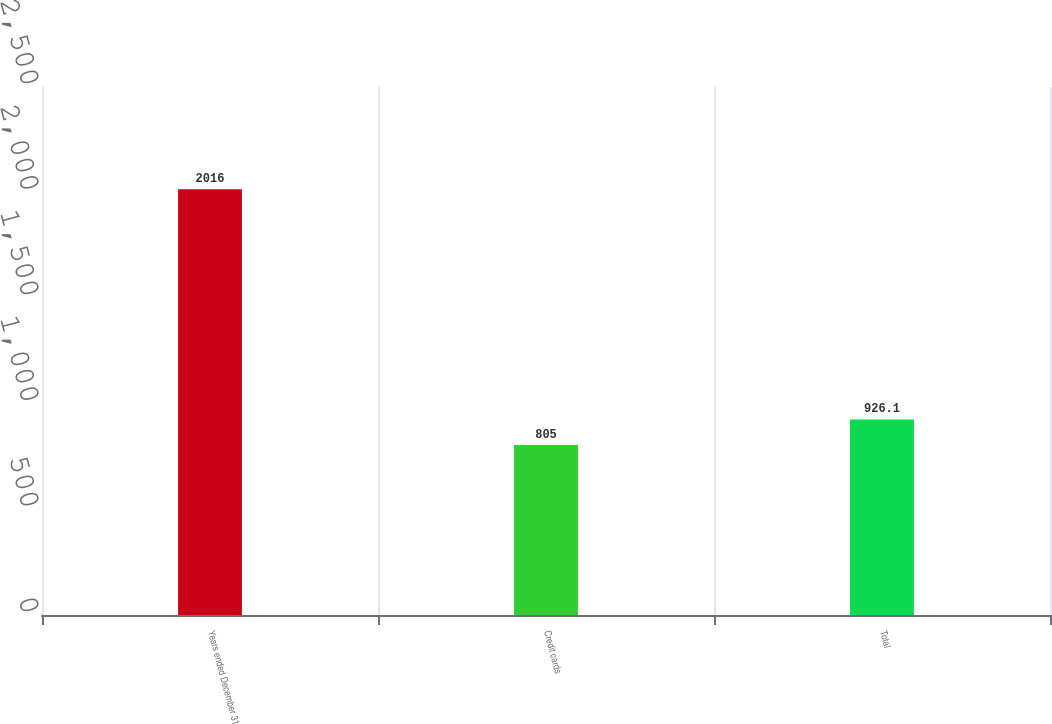Convert chart. <chart><loc_0><loc_0><loc_500><loc_500><bar_chart><fcel>Years ended December 31<fcel>Credit cards<fcel>Total<nl><fcel>2016<fcel>805<fcel>926.1<nl></chart> 